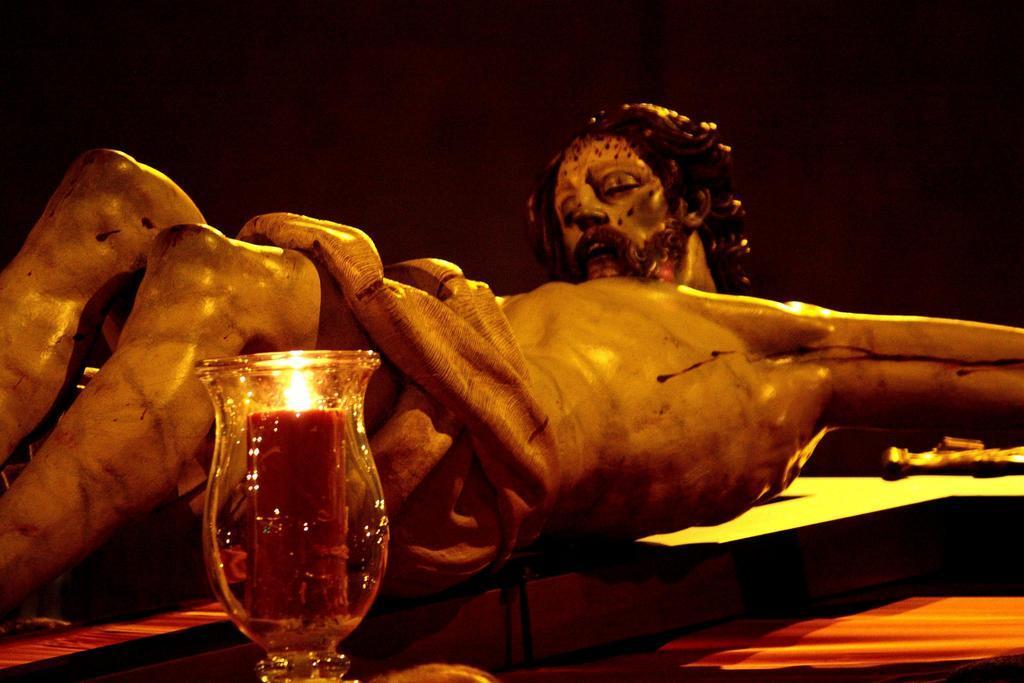In one or two sentences, can you explain what this image depicts? In this image we can see there is a statue of the Jesus Christ laid on the cross, In front of the statue there is a lamp. 